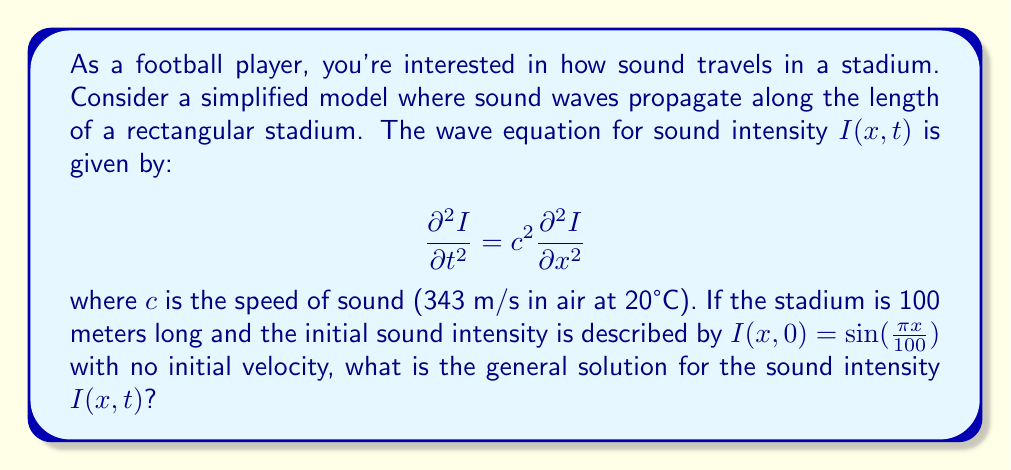Provide a solution to this math problem. To solve this problem, we'll follow these steps:

1) The general solution to the wave equation in this case is of the form:

   $$I(x,t) = [A \cos(ωt) + B \sin(ωt)] \sin(kx)$$

   where $ω$ is the angular frequency and $k$ is the wave number.

2) From the initial condition $I(x,0) = \sin(\frac{\pi x}{100})$, we can deduce:

   $k = \frac{\pi}{100}$

3) The relationship between $ω$, $k$, and $c$ is:

   $$ω = ck = c\frac{\pi}{100}$$

4) Substituting these into the general solution:

   $$I(x,t) = [A \cos(\frac{c\pi t}{100}) + B \sin(\frac{c\pi t}{100})] \sin(\frac{\pi x}{100})$$

5) To determine $A$ and $B$, we use the initial conditions:

   At $t=0$: $I(x,0) = A \sin(\frac{\pi x}{100}) = \sin(\frac{\pi x}{100})$
   Therefore, $A = 1$

   The initial velocity is zero, so:
   $$\frac{\partial I}{\partial t}(x,0) = \frac{c\pi}{100}[-A \sin(\frac{c\pi t}{100}) + B \cos(\frac{c\pi t}{100})]\sin(\frac{\pi x}{100}) = 0$$
   At $t=0$, this gives: $B = 0$

6) Therefore, the final solution is:

   $$I(x,t) = \cos(\frac{c\pi t}{100}) \sin(\frac{\pi x}{100})$$
Answer: $I(x,t) = \cos(\frac{343\pi t}{100}) \sin(\frac{\pi x}{100})$ 